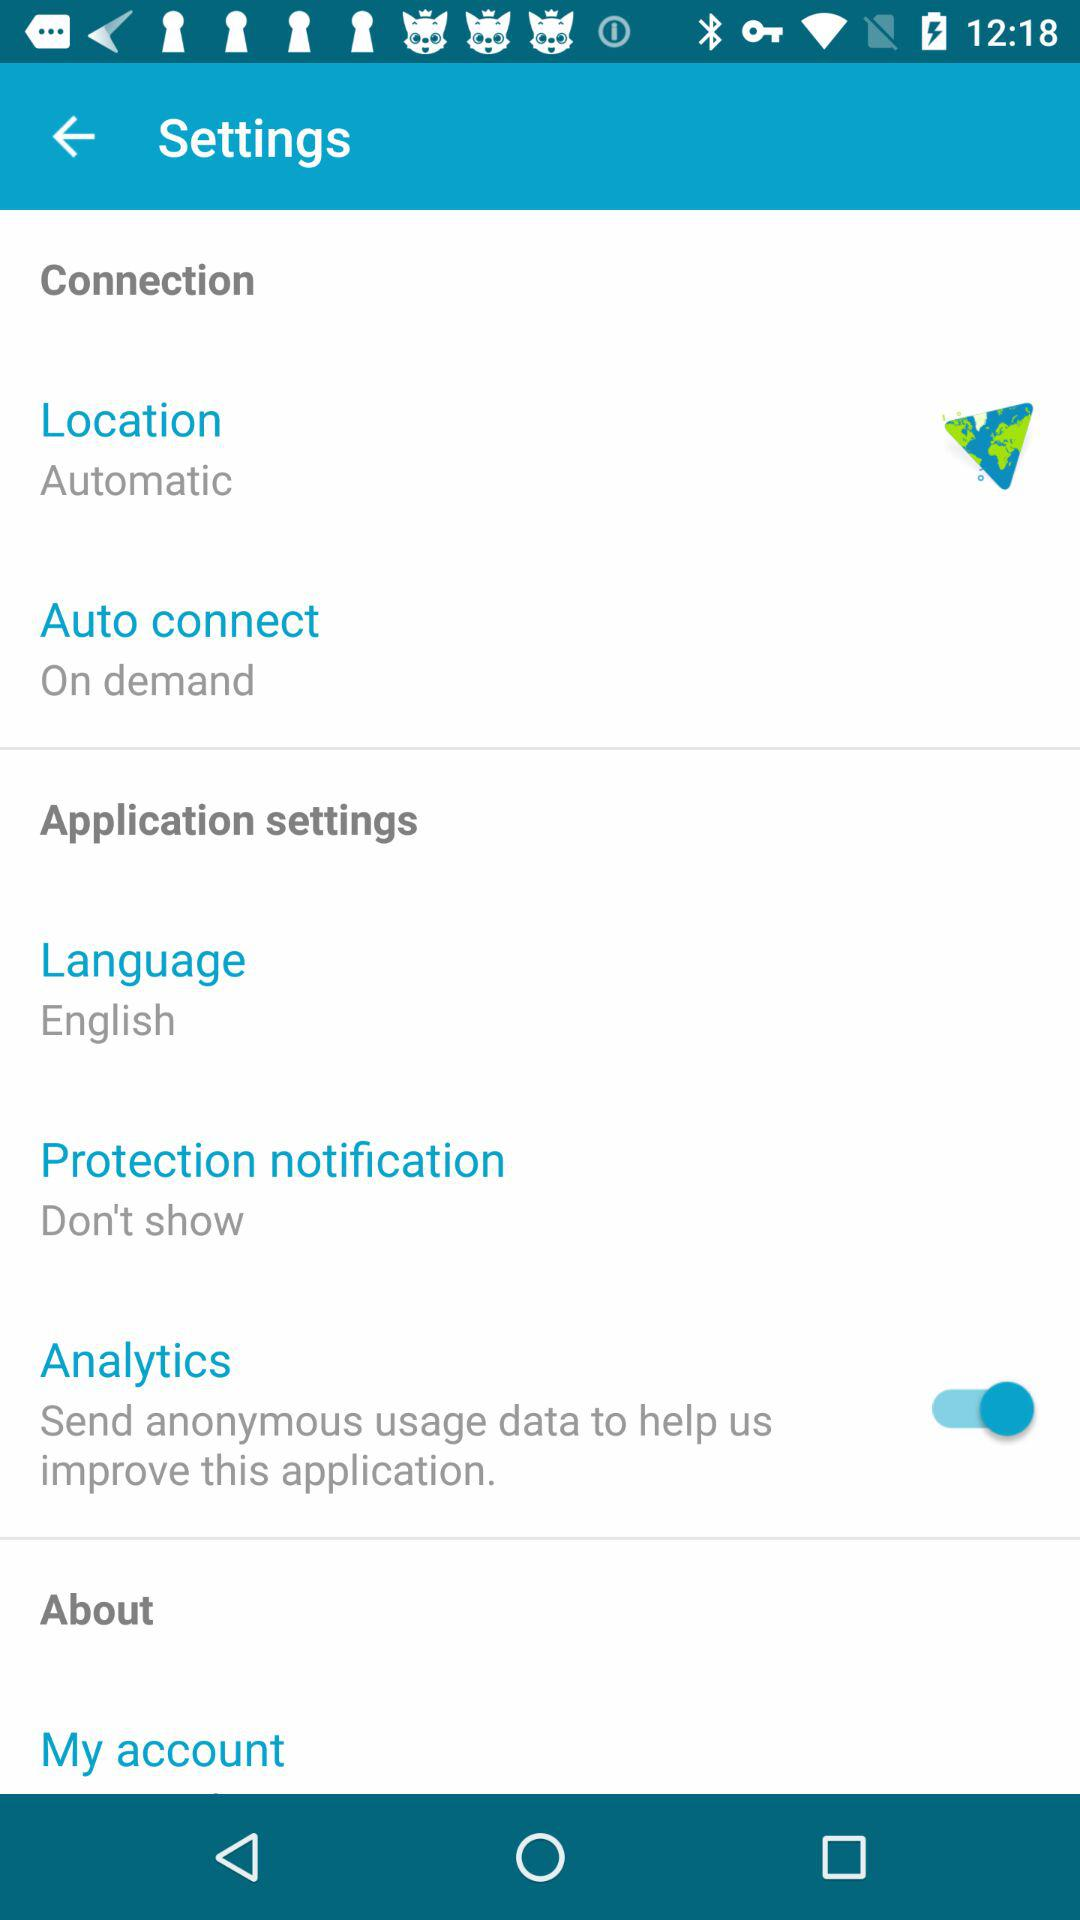What is the setting for protection notification? The setting is "Don't show". 